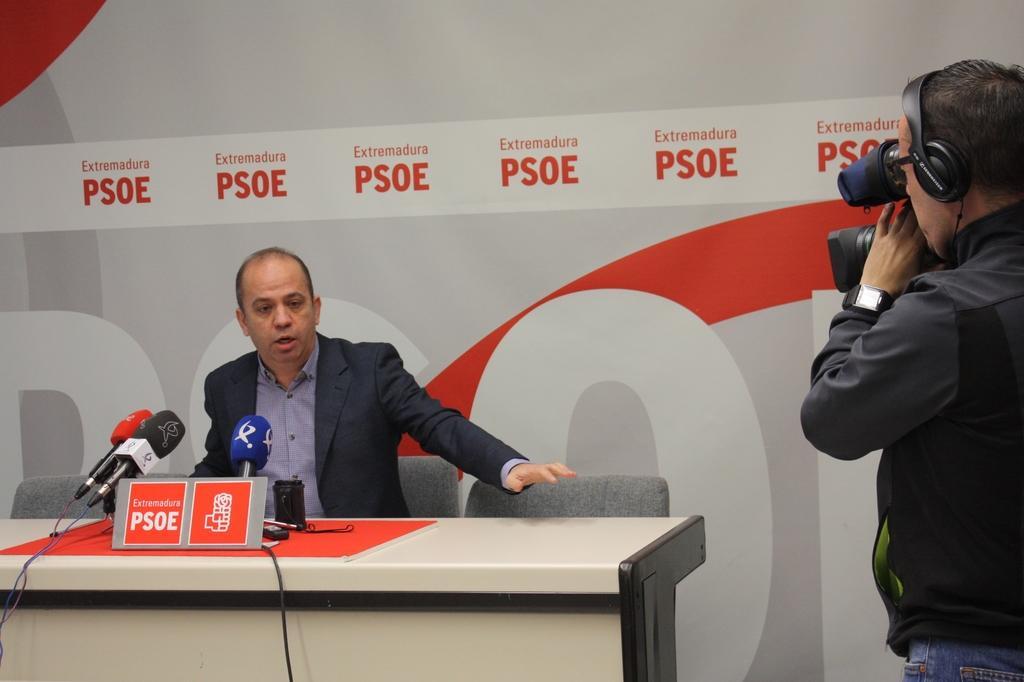How would you summarize this image in a sentence or two? In this image, In the left side there is a table which is in white color on that there are some microphones, there is a person siting on the chair and he is speaking in the microphone, In the right side there is a man standing and he is holding a camera which is in black color, In the background there is a white color wall. 